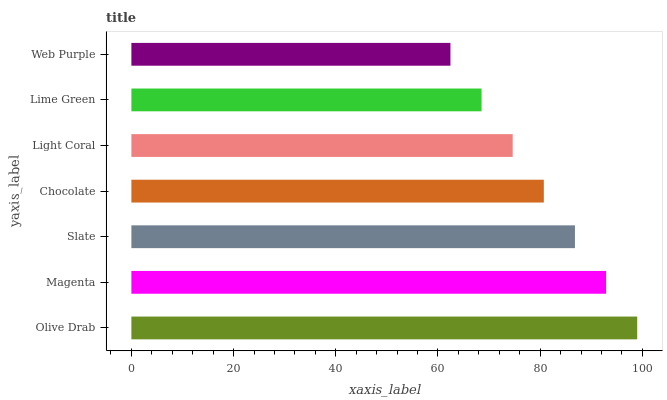Is Web Purple the minimum?
Answer yes or no. Yes. Is Olive Drab the maximum?
Answer yes or no. Yes. Is Magenta the minimum?
Answer yes or no. No. Is Magenta the maximum?
Answer yes or no. No. Is Olive Drab greater than Magenta?
Answer yes or no. Yes. Is Magenta less than Olive Drab?
Answer yes or no. Yes. Is Magenta greater than Olive Drab?
Answer yes or no. No. Is Olive Drab less than Magenta?
Answer yes or no. No. Is Chocolate the high median?
Answer yes or no. Yes. Is Chocolate the low median?
Answer yes or no. Yes. Is Slate the high median?
Answer yes or no. No. Is Light Coral the low median?
Answer yes or no. No. 